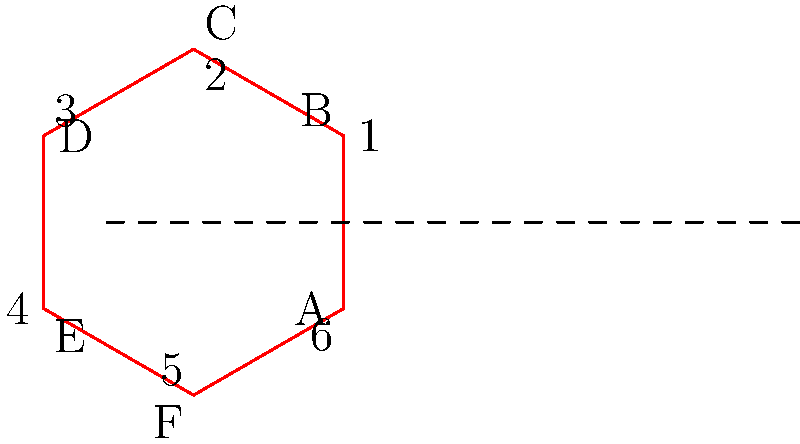Your child is learning about mirror images in their ethical hacking class. They show you this diagram and ask which of the numbered points corresponds to point C in the mirror image. Can you help them identify the correct point? To solve this problem, let's follow these steps:

1. Understand the concept of mirror images: In a mirror image, each point is reflected across the line of reflection (shown as a dashed line in the diagram).

2. Identify the line of reflection: The dashed line in the middle of the diagram represents the mirror or line of reflection.

3. Locate point C: Point C is at the top right corner of the blue hexagon.

4. Visualize the reflection: Imagine a perpendicular line from point C to the line of reflection, and then extend it an equal distance on the other side.

5. Find the corresponding point: The point that matches this position in the red hexagon is point 3.

6. Verify: Check that point 3 is in the same relative position (top right corner) of the red hexagon as point C is in the blue hexagon.

By following these steps, we can conclude that point 3 corresponds to point C in the mirror image.
Answer: 3 